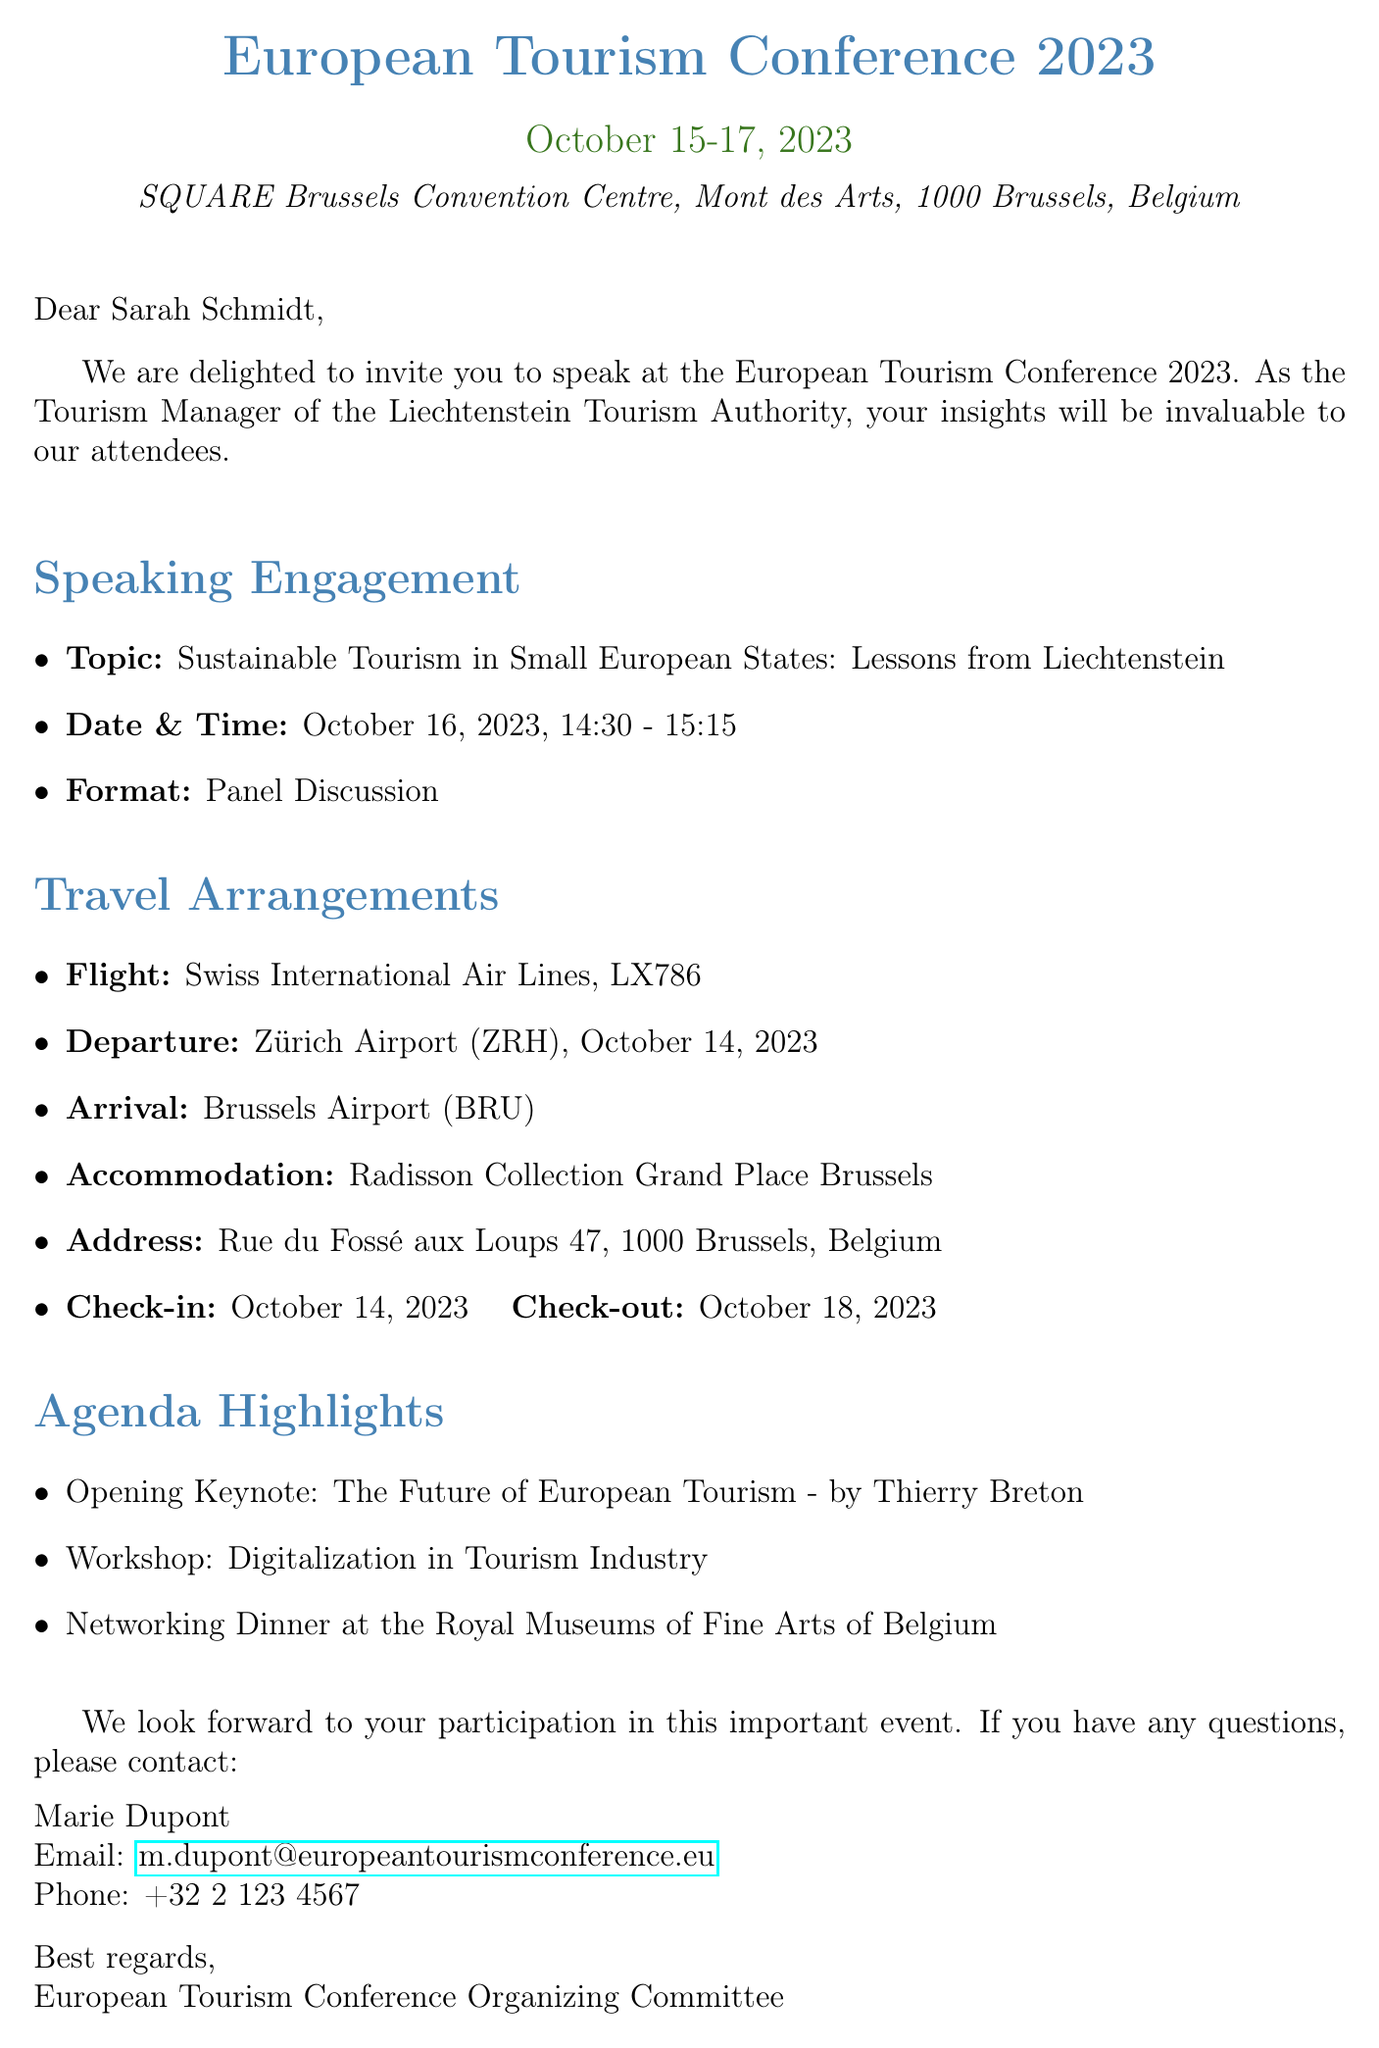What is the date of the conference? The date of the European Tourism Conference 2023 is mentioned as October 15-17, 2023.
Answer: October 15-17, 2023 Who is the keynote speaker? The document mentions Thierry Breton as the keynote speaker for the opening session.
Answer: Thierry Breton What is the topic of the speaking engagement? The document specifies the topic of the speaking engagement as "Sustainable Tourism in Small European States: Lessons from Liechtenstein".
Answer: Sustainable Tourism in Small European States: Lessons from Liechtenstein What is the check-out date for the accommodation? The check-out date for the hotel stay is explicitly stated in the travel arrangements section.
Answer: October 18, 2023 What time does the speaking engagement start? The document states that the speaking engagement starts at 14:30.
Answer: 14:30 How long is the panel discussion scheduled for? The duration of the panel discussion can be calculated from the start and end time provided in the document.
Answer: 45 minutes What airline is providing the flight? The travel arrangements section lists Swiss International Air Lines as the airline for the flight.
Answer: Swiss International Air Lines Who should I contact if I have questions? The document provides contact information for Marie Dupont for any inquiries related to the conference.
Answer: Marie Dupont 